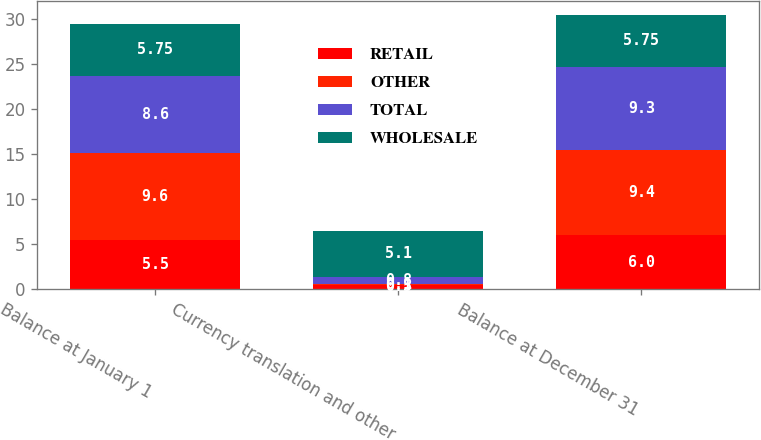<chart> <loc_0><loc_0><loc_500><loc_500><stacked_bar_chart><ecel><fcel>Balance at January 1<fcel>Currency translation and other<fcel>Balance at December 31<nl><fcel>RETAIL<fcel>5.5<fcel>0.5<fcel>6<nl><fcel>OTHER<fcel>9.6<fcel>0.1<fcel>9.4<nl><fcel>TOTAL<fcel>8.6<fcel>0.8<fcel>9.3<nl><fcel>WHOLESALE<fcel>5.75<fcel>5.1<fcel>5.75<nl></chart> 